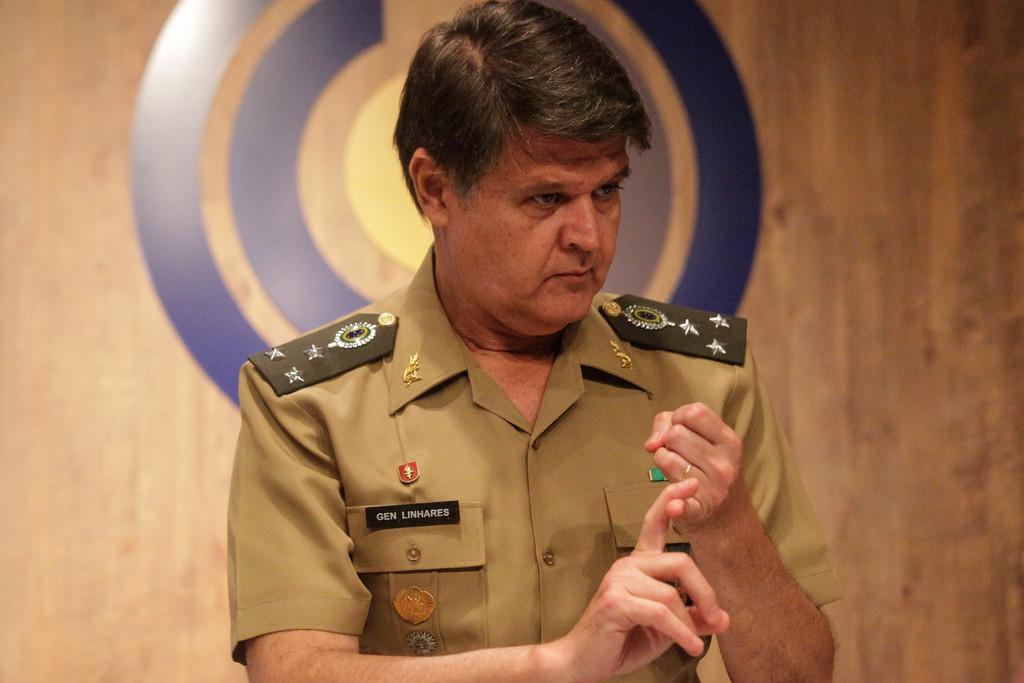What is the main subject of the image? There is a person in the image. Can you describe the background of the image? There is a wooden wall in the background of the image. How many cows can be seen grazing in the image? There are no cows present in the image. What type of animal is serving the person in the image? There is no animal serving the person in the image, nor is there a servant present. 